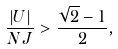Convert formula to latex. <formula><loc_0><loc_0><loc_500><loc_500>\frac { | U | } { N J } > \frac { \sqrt { 2 } - 1 } { 2 } ,</formula> 